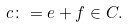<formula> <loc_0><loc_0><loc_500><loc_500>c \colon = e + f \in C .</formula> 